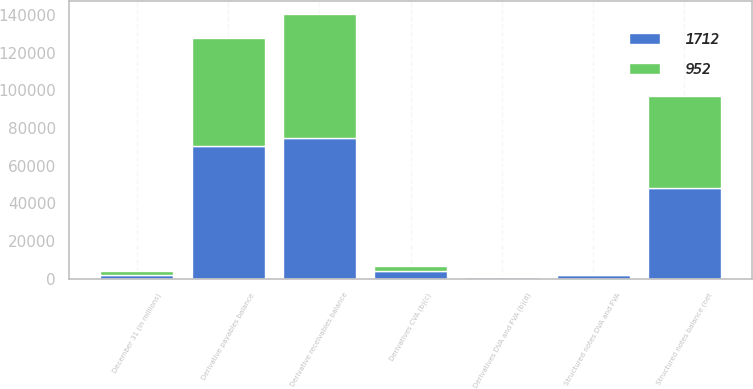Convert chart. <chart><loc_0><loc_0><loc_500><loc_500><stacked_bar_chart><ecel><fcel>December 31 (in millions)<fcel>Derivative receivables balance<fcel>Derivative payables balance<fcel>Derivatives CVA (b)(c)<fcel>Derivatives DVA and FVA (b)(d)<fcel>Structured notes balance (net<fcel>Structured notes DVA and FVA<nl><fcel>952<fcel>2013<fcel>65759<fcel>57314<fcel>2352<fcel>322<fcel>48808<fcel>952<nl><fcel>1712<fcel>2012<fcel>74983<fcel>70656<fcel>4238<fcel>830<fcel>48112<fcel>1712<nl></chart> 